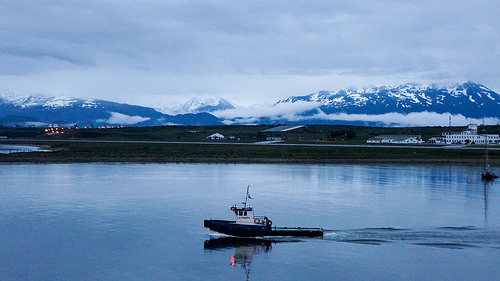<image>
Is there a water in the boat? No. The water is not contained within the boat. These objects have a different spatial relationship. 